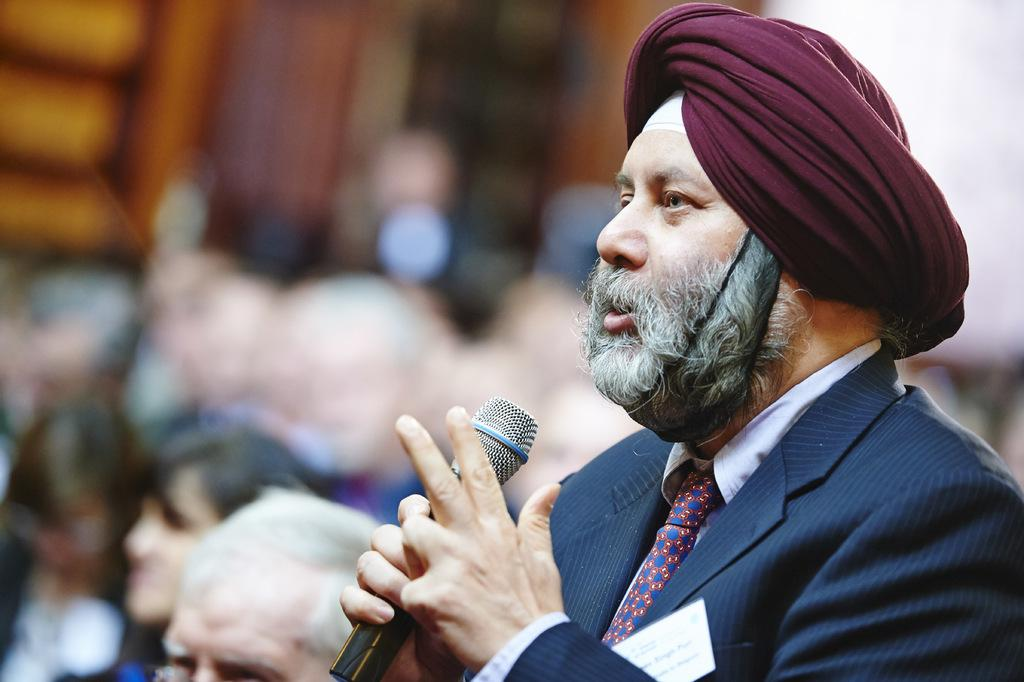Who or what can be seen in the image? There is a person present in the image. What is the person wearing? The person is wearing a blue color suit. What is the person holding in his hand? The person is holding a microphone in his hand. Where is the sofa located in the image? There is no sofa present in the image. What word is being spoken into the microphone in the image? The image does not provide any information about the word being spoken into the microphone. 